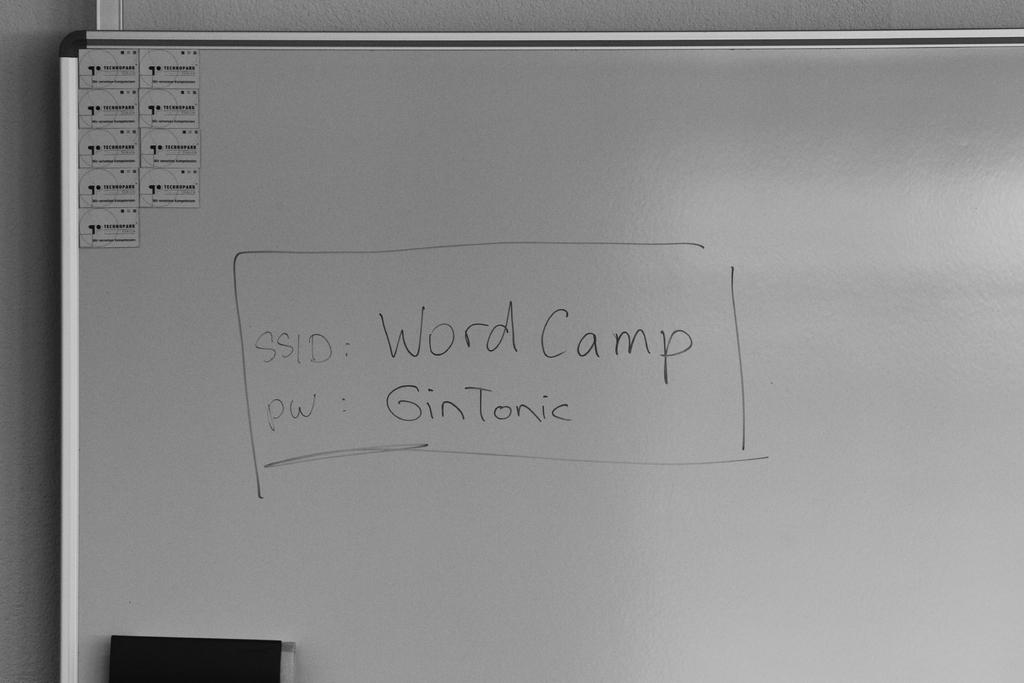<image>
Give a short and clear explanation of the subsequent image. A whiteboard that shows an ID as WordCamp and the password as GinTonic. 